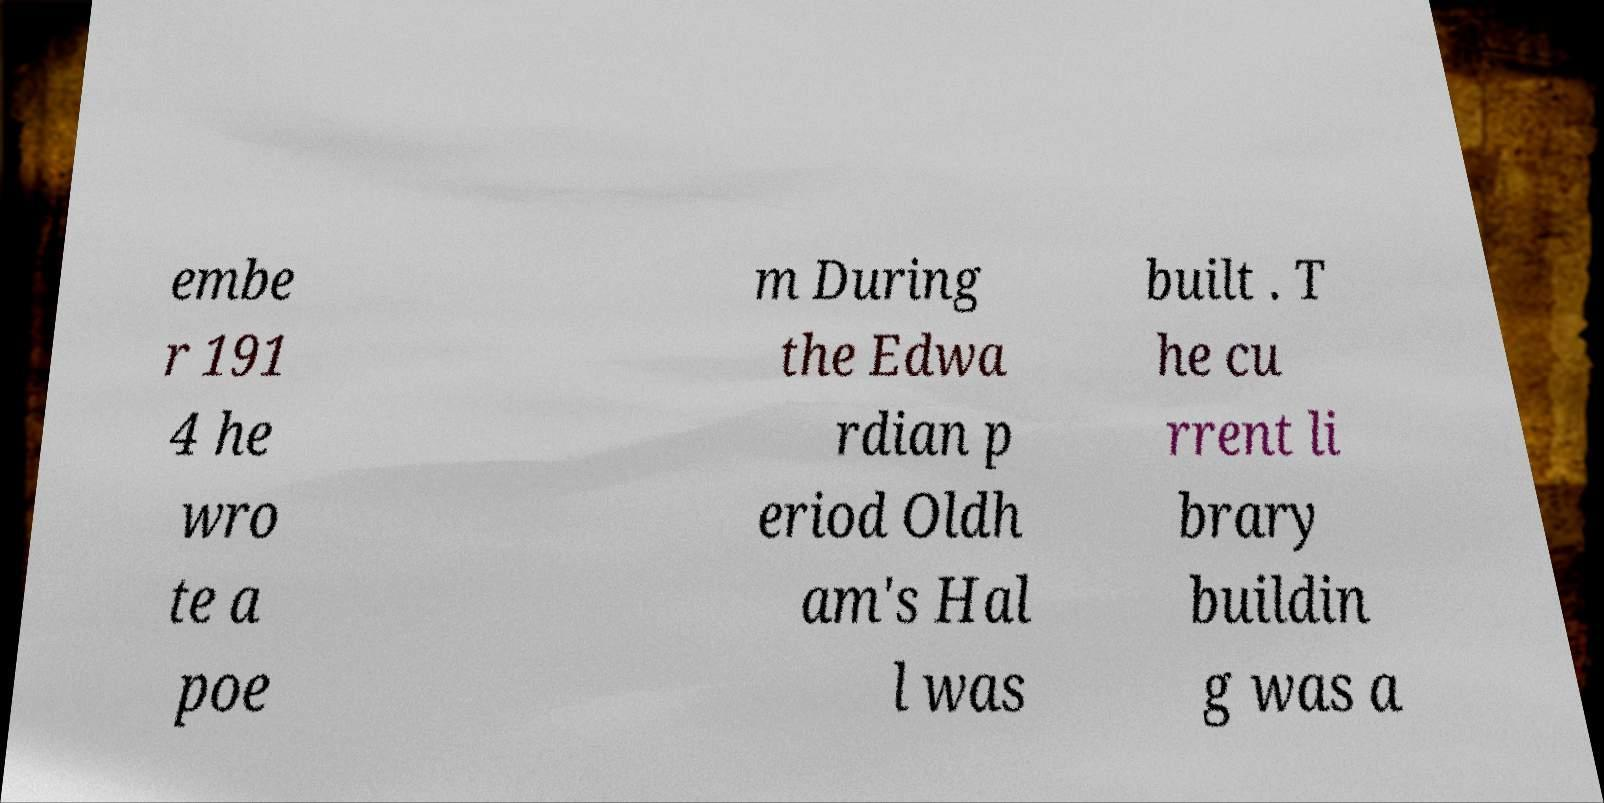Please identify and transcribe the text found in this image. embe r 191 4 he wro te a poe m During the Edwa rdian p eriod Oldh am's Hal l was built . T he cu rrent li brary buildin g was a 